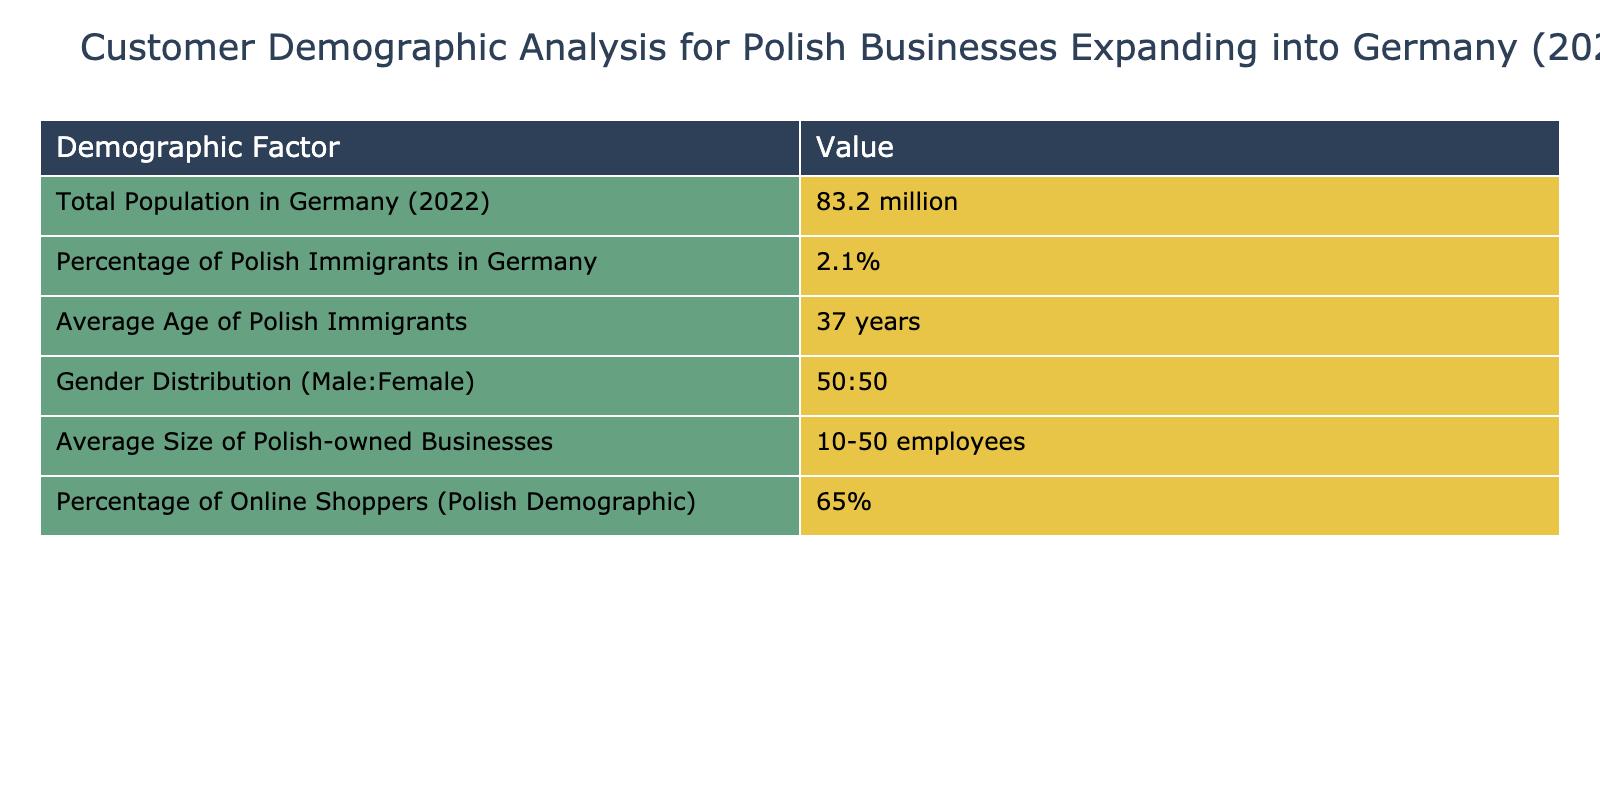What is the total population in Germany for the year 2022? The table states that the total population in Germany in 2022 is specifically mentioned as 83.2 million.
Answer: 83.2 million What percentage of the population in Germany are Polish immigrants? According to the data, it is explicitly indicated that Polish immigrants make up 2.1% of the German population.
Answer: 2.1% What is the average age of Polish immigrants in Germany? The table reveals that the average age of Polish immigrants in Germany is documented as 37 years.
Answer: 37 years What is the gender distribution among Polish immigrants in Germany? The data shows that the gender distribution among Polish immigrants is equal, with a ratio of 50:50 for males and females.
Answer: 50:50 How many employees do Polish-owned businesses typically have? The average size of Polish-owned businesses in Germany, based on the table, is between 10 to 50 employees.
Answer: 10-50 employees What percentage of Polish immigrants shop online? The data states that 65% of the Polish demographic in Germany are online shoppers.
Answer: 65% Is the average age of Polish immigrants greater than 35 years? The average age of Polish immigrants, as per the table, is 37 years, which is indeed greater than 35.
Answer: Yes Are there more Polish male immigrants than female immigrants in Germany? The gender distribution provided in the table indicates a 50:50 ratio, meaning there are equal numbers of male and female Polish immigrants. Thus, there are not more males than females.
Answer: No What is the total population of Polish immigrants if we know 2.1% of the total German population is Polish? To find the number of Polish immigrants, calculate 2.1% of the total population of Germany (83.2 million). This can be done as follows: 0.021 * 83.2 million = 1.747 million. Thus, the total is approximately 1.747 million.
Answer: 1.747 million If only 65% of Polish immigrants shop online, how many do not engage in online shopping? First, determine the number of Polish immigrants in Germany (1.747 million). Then, calculate 35% who do not shop online: 0.35 * 1.747 million = 0.61145 million. Therefore, approximately 611,450 Polish immigrants do not engage in online shopping.
Answer: 611,450 